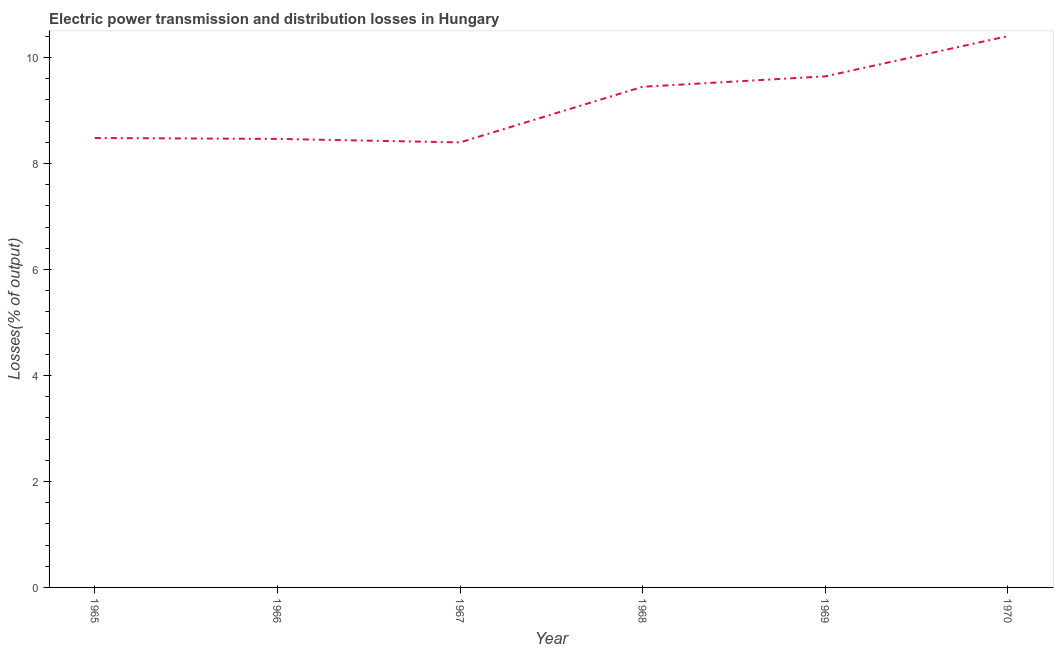What is the electric power transmission and distribution losses in 1968?
Your answer should be very brief. 9.45. Across all years, what is the maximum electric power transmission and distribution losses?
Keep it short and to the point. 10.4. Across all years, what is the minimum electric power transmission and distribution losses?
Keep it short and to the point. 8.4. In which year was the electric power transmission and distribution losses minimum?
Your response must be concise. 1967. What is the sum of the electric power transmission and distribution losses?
Provide a succinct answer. 54.84. What is the difference between the electric power transmission and distribution losses in 1969 and 1970?
Your answer should be compact. -0.76. What is the average electric power transmission and distribution losses per year?
Make the answer very short. 9.14. What is the median electric power transmission and distribution losses?
Your answer should be very brief. 8.97. In how many years, is the electric power transmission and distribution losses greater than 2.8 %?
Offer a very short reply. 6. What is the ratio of the electric power transmission and distribution losses in 1967 to that in 1969?
Offer a terse response. 0.87. What is the difference between the highest and the second highest electric power transmission and distribution losses?
Your answer should be very brief. 0.76. Is the sum of the electric power transmission and distribution losses in 1965 and 1969 greater than the maximum electric power transmission and distribution losses across all years?
Provide a succinct answer. Yes. What is the difference between the highest and the lowest electric power transmission and distribution losses?
Provide a short and direct response. 2.01. In how many years, is the electric power transmission and distribution losses greater than the average electric power transmission and distribution losses taken over all years?
Provide a succinct answer. 3. How many lines are there?
Offer a very short reply. 1. How many years are there in the graph?
Make the answer very short. 6. What is the difference between two consecutive major ticks on the Y-axis?
Offer a terse response. 2. Does the graph contain any zero values?
Your response must be concise. No. What is the title of the graph?
Provide a succinct answer. Electric power transmission and distribution losses in Hungary. What is the label or title of the X-axis?
Your response must be concise. Year. What is the label or title of the Y-axis?
Offer a very short reply. Losses(% of output). What is the Losses(% of output) of 1965?
Your answer should be very brief. 8.48. What is the Losses(% of output) of 1966?
Your answer should be very brief. 8.46. What is the Losses(% of output) in 1967?
Keep it short and to the point. 8.4. What is the Losses(% of output) in 1968?
Your response must be concise. 9.45. What is the Losses(% of output) of 1969?
Your answer should be compact. 9.65. What is the Losses(% of output) in 1970?
Provide a succinct answer. 10.4. What is the difference between the Losses(% of output) in 1965 and 1966?
Your response must be concise. 0.02. What is the difference between the Losses(% of output) in 1965 and 1967?
Provide a short and direct response. 0.08. What is the difference between the Losses(% of output) in 1965 and 1968?
Keep it short and to the point. -0.97. What is the difference between the Losses(% of output) in 1965 and 1969?
Offer a very short reply. -1.16. What is the difference between the Losses(% of output) in 1965 and 1970?
Offer a terse response. -1.92. What is the difference between the Losses(% of output) in 1966 and 1967?
Offer a terse response. 0.07. What is the difference between the Losses(% of output) in 1966 and 1968?
Keep it short and to the point. -0.98. What is the difference between the Losses(% of output) in 1966 and 1969?
Your answer should be very brief. -1.18. What is the difference between the Losses(% of output) in 1966 and 1970?
Give a very brief answer. -1.94. What is the difference between the Losses(% of output) in 1967 and 1968?
Keep it short and to the point. -1.05. What is the difference between the Losses(% of output) in 1967 and 1969?
Your response must be concise. -1.25. What is the difference between the Losses(% of output) in 1967 and 1970?
Provide a short and direct response. -2.01. What is the difference between the Losses(% of output) in 1968 and 1969?
Make the answer very short. -0.2. What is the difference between the Losses(% of output) in 1968 and 1970?
Provide a short and direct response. -0.96. What is the difference between the Losses(% of output) in 1969 and 1970?
Give a very brief answer. -0.76. What is the ratio of the Losses(% of output) in 1965 to that in 1966?
Make the answer very short. 1. What is the ratio of the Losses(% of output) in 1965 to that in 1967?
Your response must be concise. 1.01. What is the ratio of the Losses(% of output) in 1965 to that in 1968?
Give a very brief answer. 0.9. What is the ratio of the Losses(% of output) in 1965 to that in 1969?
Offer a very short reply. 0.88. What is the ratio of the Losses(% of output) in 1965 to that in 1970?
Your answer should be compact. 0.81. What is the ratio of the Losses(% of output) in 1966 to that in 1967?
Provide a short and direct response. 1.01. What is the ratio of the Losses(% of output) in 1966 to that in 1968?
Provide a succinct answer. 0.9. What is the ratio of the Losses(% of output) in 1966 to that in 1969?
Keep it short and to the point. 0.88. What is the ratio of the Losses(% of output) in 1966 to that in 1970?
Your response must be concise. 0.81. What is the ratio of the Losses(% of output) in 1967 to that in 1968?
Make the answer very short. 0.89. What is the ratio of the Losses(% of output) in 1967 to that in 1969?
Your response must be concise. 0.87. What is the ratio of the Losses(% of output) in 1967 to that in 1970?
Make the answer very short. 0.81. What is the ratio of the Losses(% of output) in 1968 to that in 1969?
Give a very brief answer. 0.98. What is the ratio of the Losses(% of output) in 1968 to that in 1970?
Make the answer very short. 0.91. What is the ratio of the Losses(% of output) in 1969 to that in 1970?
Ensure brevity in your answer.  0.93. 